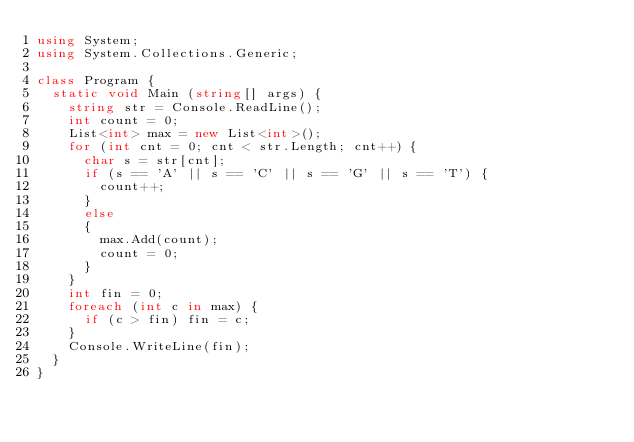<code> <loc_0><loc_0><loc_500><loc_500><_C#_>using System;
using System.Collections.Generic;
 
class Program {
  static void Main (string[] args) {
    string str = Console.ReadLine();
    int count = 0;
    List<int> max = new List<int>();
    for (int cnt = 0; cnt < str.Length; cnt++) {
      char s = str[cnt];
      if (s == 'A' || s == 'C' || s == 'G' || s == 'T') {
        count++;
      }
      else
      {
        max.Add(count);
        count = 0;
      }
    }
    int fin = 0;
    foreach (int c in max) {
      if (c > fin) fin = c;
    }
    Console.WriteLine(fin);
  }
}</code> 